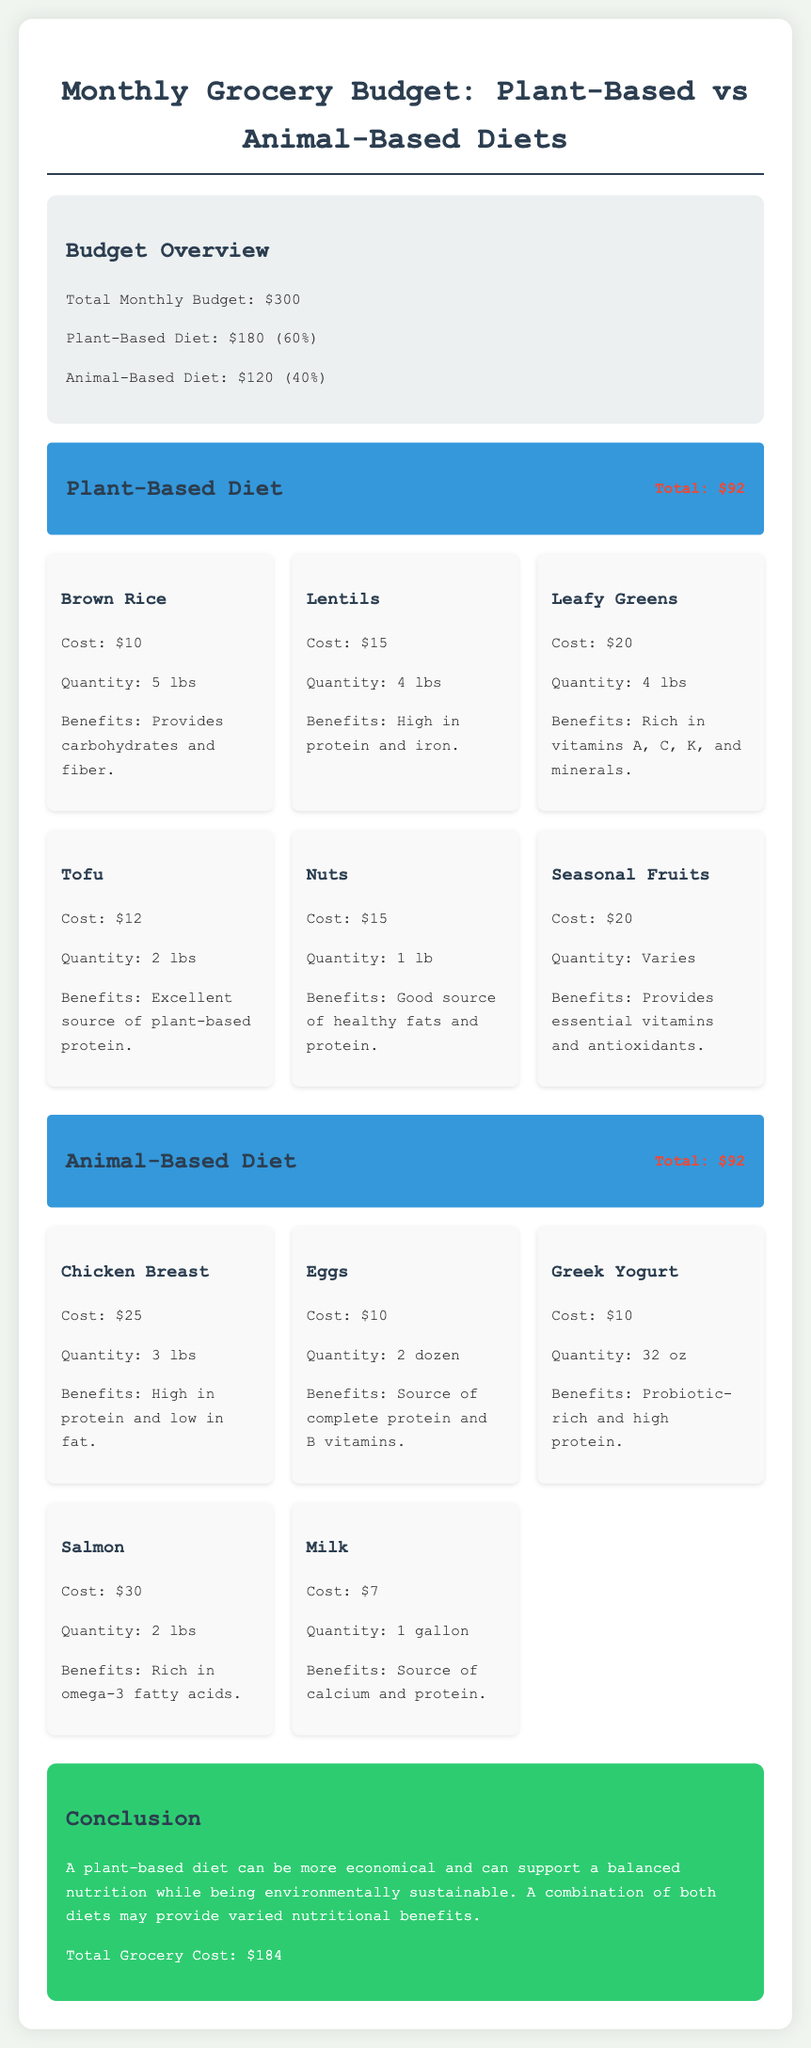What is the total monthly budget? The total monthly budget is stated in the document as $300.
Answer: $300 How much is allocated to the plant-based diet? The document specifies that the plant-based diet costs $180.
Answer: $180 What is the cost of lentils? The cost of lentils is provided in the document as $15.
Answer: $15 Which item has the highest cost in the animal-based diet? The highest cost item is salmon, which costs $30.
Answer: $30 What percentage of the budget is spent on animal-based diets? The document indicates that animal-based diets account for 40% of the budget.
Answer: 40% What is the total cost for the plant-based diet? The total cost for the plant-based diet is given as $92.
Answer: $92 How many pounds of chicken breast can be purchased for $25? The document states that $25 buys 3 lbs of chicken breast.
Answer: 3 lbs What benefit is associated with nuts in the plant-based section? The document mentions that nuts are a good source of healthy fats and protein.
Answer: Healthy fats and protein What is the total grocery cost according to the conclusion? The total grocery cost mentioned in the conclusion is $184.
Answer: $184 